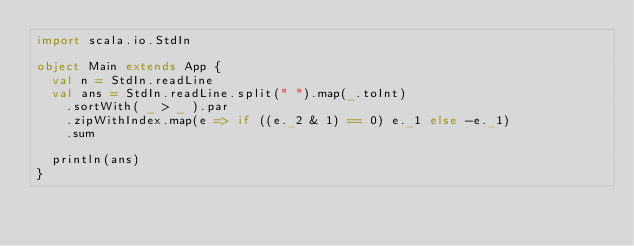<code> <loc_0><loc_0><loc_500><loc_500><_Scala_>import scala.io.StdIn

object Main extends App {
  val n = StdIn.readLine
  val ans = StdIn.readLine.split(" ").map(_.toInt)
    .sortWith( _ > _ ).par
    .zipWithIndex.map(e => if ((e._2 & 1) == 0) e._1 else -e._1)
    .sum

  println(ans)
}
</code> 